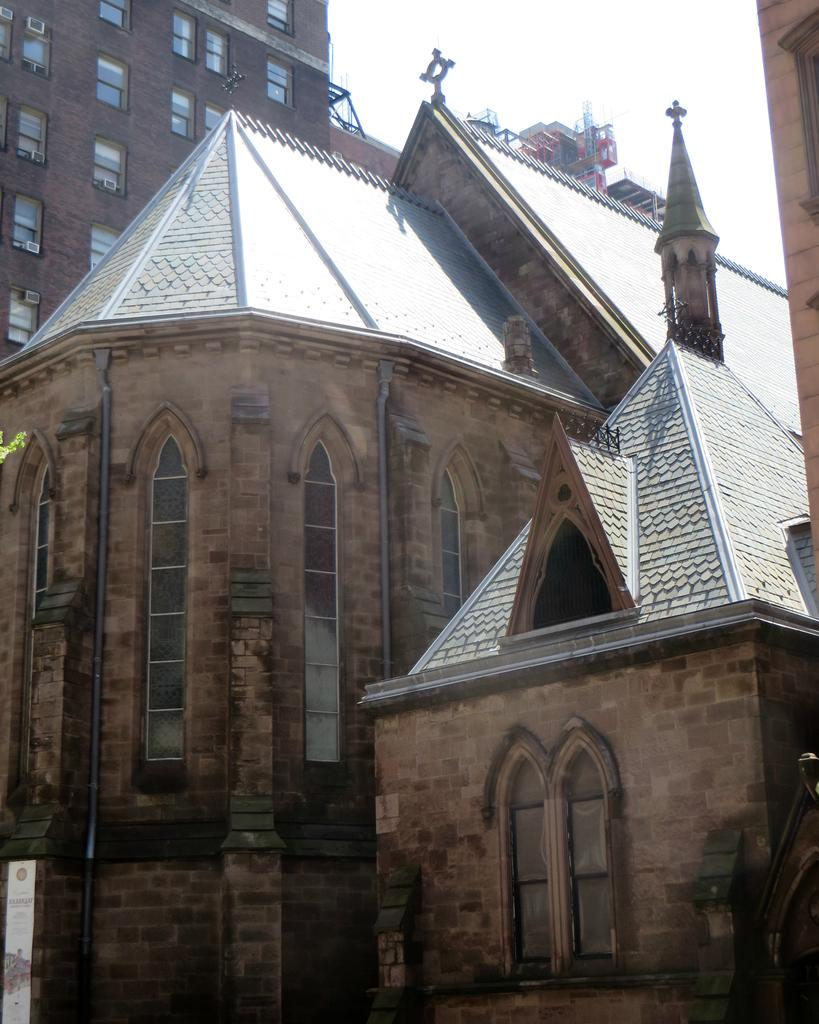What type of structures are present in the image? There are buildings with windows in the image. What can be seen in the sky in the image? The sky is visible at the top of the image. Where is the banner located in the image? The banner is in the bottom left corner of the image. Can you see any owls sitting on the windowsills of the buildings in the image? There are no owls visible in the image; it only features buildings with windows and a banner. What type of key is used to unlock the doors of the buildings in the image? There is no information about keys or door locks in the image, as it only shows buildings with windows and a banner. 